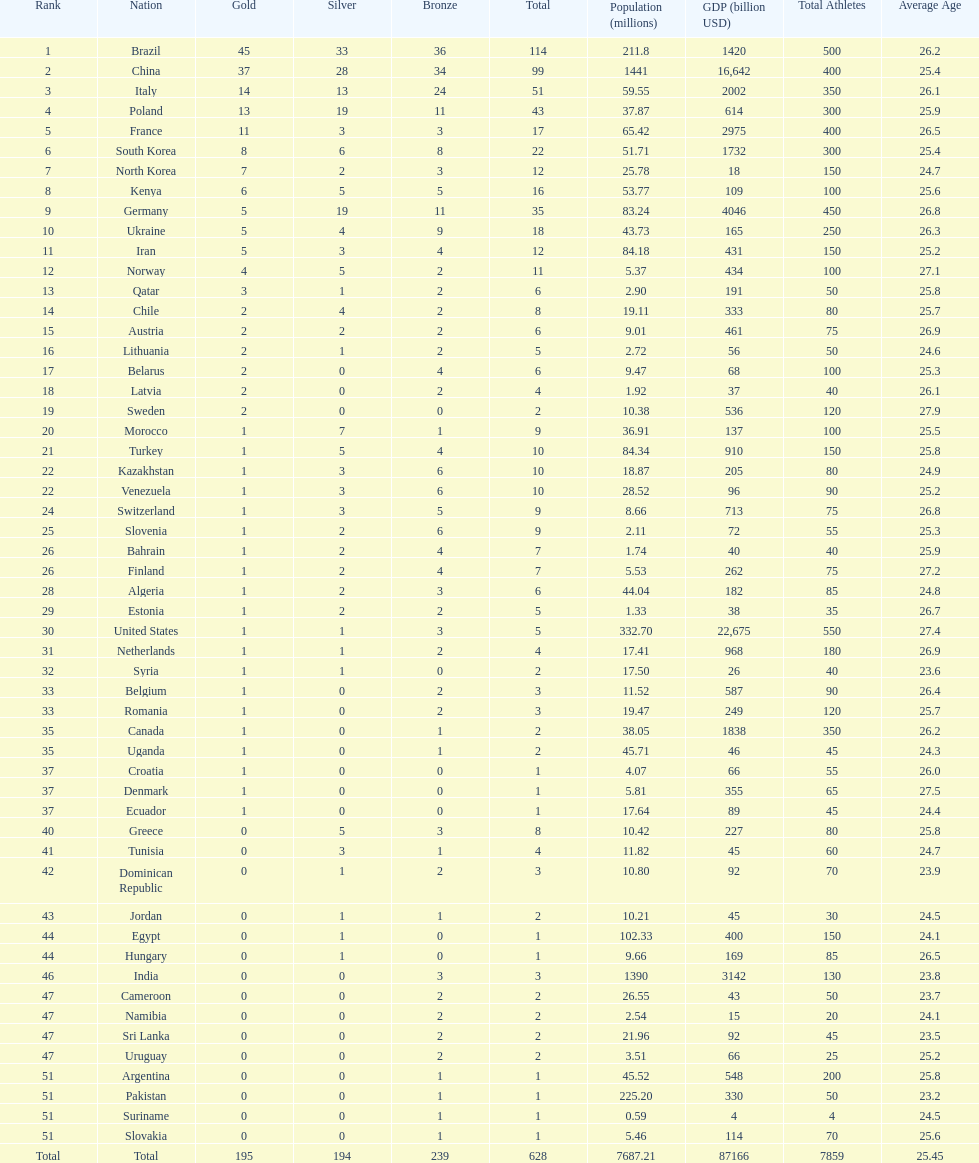Parse the table in full. {'header': ['Rank', 'Nation', 'Gold', 'Silver', 'Bronze', 'Total', 'Population (millions)', 'GDP (billion USD)', 'Total Athletes', 'Average Age'], 'rows': [['1', 'Brazil', '45', '33', '36', '114', '211.8', '1420', '500', '26.2'], ['2', 'China', '37', '28', '34', '99', '1441', '16,642', '400', '25.4'], ['3', 'Italy', '14', '13', '24', '51', '59.55', '2002', '350', '26.1'], ['4', 'Poland', '13', '19', '11', '43', '37.87', '614', '300', '25.9'], ['5', 'France', '11', '3', '3', '17', '65.42', '2975', '400', '26.5'], ['6', 'South Korea', '8', '6', '8', '22', '51.71', '1732', '300', '25.4'], ['7', 'North Korea', '7', '2', '3', '12', '25.78', '18', '150', '24.7'], ['8', 'Kenya', '6', '5', '5', '16', '53.77', '109', '100', '25.6'], ['9', 'Germany', '5', '19', '11', '35', '83.24', '4046', '450', '26.8'], ['10', 'Ukraine', '5', '4', '9', '18', '43.73', '165', '250', '26.3'], ['11', 'Iran', '5', '3', '4', '12', '84.18', '431', '150', '25.2'], ['12', 'Norway', '4', '5', '2', '11', '5.37', '434', '100', '27.1'], ['13', 'Qatar', '3', '1', '2', '6', '2.90', '191', '50', '25.8'], ['14', 'Chile', '2', '4', '2', '8', '19.11', '333', '80', '25.7'], ['15', 'Austria', '2', '2', '2', '6', '9.01', '461', '75', '26.9'], ['16', 'Lithuania', '2', '1', '2', '5', '2.72', '56', '50', '24.6'], ['17', 'Belarus', '2', '0', '4', '6', '9.47', '68', '100', '25.3'], ['18', 'Latvia', '2', '0', '2', '4', '1.92', '37', '40', '26.1'], ['19', 'Sweden', '2', '0', '0', '2', '10.38', '536', '120', '27.9'], ['20', 'Morocco', '1', '7', '1', '9', '36.91', '137', '100', '25.5'], ['21', 'Turkey', '1', '5', '4', '10', '84.34', '910', '150', '25.8'], ['22', 'Kazakhstan', '1', '3', '6', '10', '18.87', '205', '80', '24.9'], ['22', 'Venezuela', '1', '3', '6', '10', '28.52', '96', '90', '25.2'], ['24', 'Switzerland', '1', '3', '5', '9', '8.66', '713', '75', '26.8'], ['25', 'Slovenia', '1', '2', '6', '9', '2.11', '72', '55', '25.3'], ['26', 'Bahrain', '1', '2', '4', '7', '1.74', '40', '40', '25.9'], ['26', 'Finland', '1', '2', '4', '7', '5.53', '262', '75', '27.2'], ['28', 'Algeria', '1', '2', '3', '6', '44.04', '182', '85', '24.8'], ['29', 'Estonia', '1', '2', '2', '5', '1.33', '38', '35', '26.7'], ['30', 'United States', '1', '1', '3', '5', '332.70', '22,675', '550', '27.4'], ['31', 'Netherlands', '1', '1', '2', '4', '17.41', '968', '180', '26.9'], ['32', 'Syria', '1', '1', '0', '2', '17.50', '26', '40', '23.6'], ['33', 'Belgium', '1', '0', '2', '3', '11.52', '587', '90', '26.4'], ['33', 'Romania', '1', '0', '2', '3', '19.47', '249', '120', '25.7'], ['35', 'Canada', '1', '0', '1', '2', '38.05', '1838', '350', '26.2'], ['35', 'Uganda', '1', '0', '1', '2', '45.71', '46', '45', '24.3'], ['37', 'Croatia', '1', '0', '0', '1', '4.07', '66', '55', '26.0'], ['37', 'Denmark', '1', '0', '0', '1', '5.81', '355', '65', '27.5'], ['37', 'Ecuador', '1', '0', '0', '1', '17.64', '89', '45', '24.4'], ['40', 'Greece', '0', '5', '3', '8', '10.42', '227', '80', '25.8'], ['41', 'Tunisia', '0', '3', '1', '4', '11.82', '45', '60', '24.7'], ['42', 'Dominican Republic', '0', '1', '2', '3', '10.80', '92', '70', '23.9'], ['43', 'Jordan', '0', '1', '1', '2', '10.21', '45', '30', '24.5'], ['44', 'Egypt', '0', '1', '0', '1', '102.33', '400', '150', '24.1'], ['44', 'Hungary', '0', '1', '0', '1', '9.66', '169', '85', '26.5'], ['46', 'India', '0', '0', '3', '3', '1390', '3142', '130', '23.8'], ['47', 'Cameroon', '0', '0', '2', '2', '26.55', '43', '50', '23.7'], ['47', 'Namibia', '0', '0', '2', '2', '2.54', '15', '20', '24.1'], ['47', 'Sri Lanka', '0', '0', '2', '2', '21.96', '92', '45', '23.5'], ['47', 'Uruguay', '0', '0', '2', '2', '3.51', '66', '25', '25.2'], ['51', 'Argentina', '0', '0', '1', '1', '45.52', '548', '200', '25.8'], ['51', 'Pakistan', '0', '0', '1', '1', '225.20', '330', '50', '23.2'], ['51', 'Suriname', '0', '0', '1', '1', '0.59', '4', '4', '24.5'], ['51', 'Slovakia', '0', '0', '1', '1', '5.46', '114', '70', '25.6'], ['Total', 'Total', '195', '194', '239', '628', '7687.21', '87166', '7859', '25.45']]} Did italy or norway have 51 total medals? Italy. 